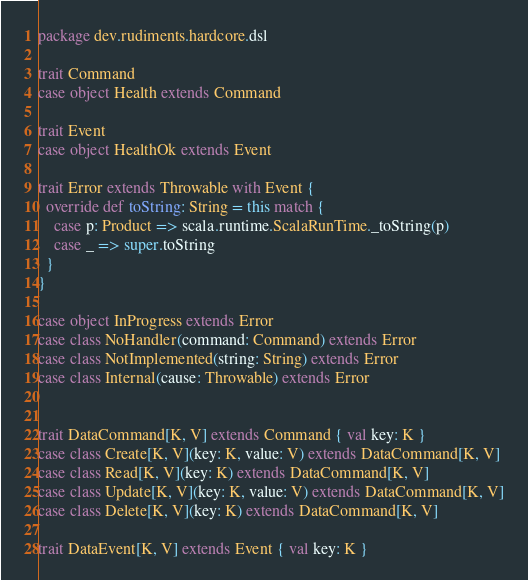<code> <loc_0><loc_0><loc_500><loc_500><_Scala_>package dev.rudiments.hardcore.dsl

trait Command
case object Health extends Command

trait Event
case object HealthOk extends Event

trait Error extends Throwable with Event {
  override def toString: String = this match {
    case p: Product => scala.runtime.ScalaRunTime._toString(p)
    case _ => super.toString
  }
}

case object InProgress extends Error
case class NoHandler(command: Command) extends Error
case class NotImplemented(string: String) extends Error
case class Internal(cause: Throwable) extends Error


trait DataCommand[K, V] extends Command { val key: K }
case class Create[K, V](key: K, value: V) extends DataCommand[K, V]
case class Read[K, V](key: K) extends DataCommand[K, V]
case class Update[K, V](key: K, value: V) extends DataCommand[K, V]
case class Delete[K, V](key: K) extends DataCommand[K, V]

trait DataEvent[K, V] extends Event { val key: K }</code> 